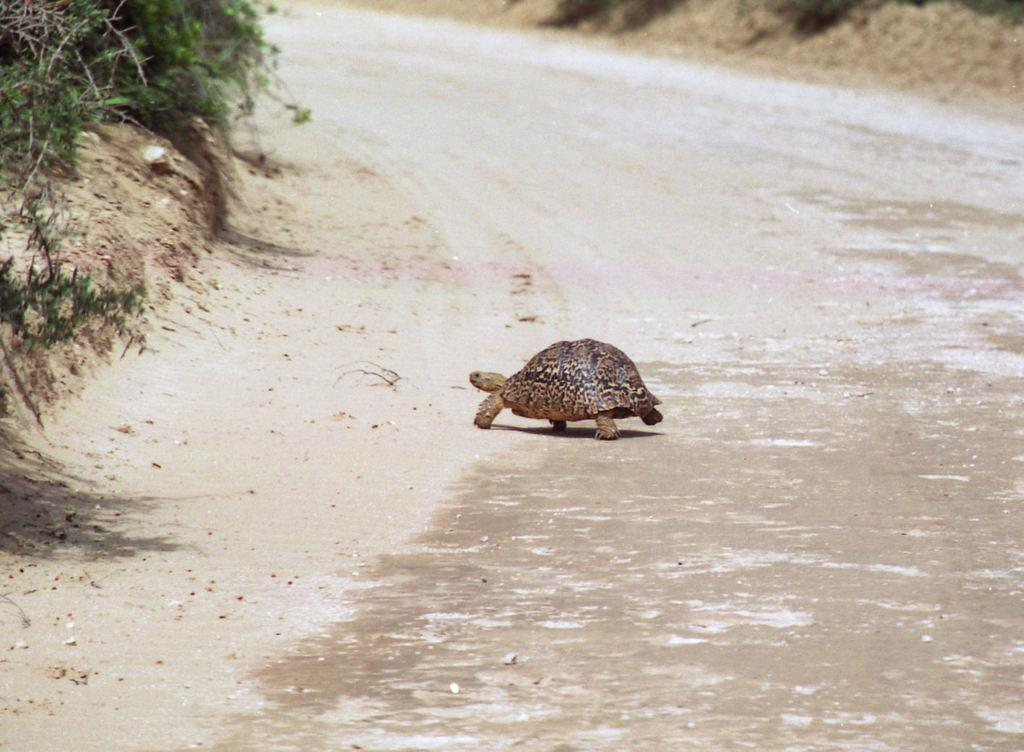What animal is present in the image? There is a tortoise in the image. Where is the tortoise located? The tortoise is on the ground. What can be seen in the background of the image? There are trees in the background of the image. What is the tortoise attacking in the image? The tortoise is not attacking anything in the image. --- Facts: 1. There is a car in the image. 2. The car is red. 3. The car has four wheels. 4. There is a person standing next to the car. 5. The person is holding a phone. Absurd Topics: dinosaur, piano, ocean Conversation: What is the main subject in the image? There is a car in the image. What color is the car? The car is red. How many wheels does the car have? The car has four wheels. Is there a person in the image? Yes, there is a person standing next to the car. What is the person holding? The person is holding a phone. Reasoning: Let's think step by step in order to ${produce the conversation}. We start by identifying the main subject of the image, which is the car. Next, we describe specific features of the car, such as the color and the number of wheels. Then, we observe the actions of the person in the image, noting that they are holding a phone. Finally, we ensure that the language is simple and clear. Absurd Question/Answer: Can you see a dinosaur playing a piano in the ocean in the image? No, there is no dinosaur playing a piano in the ocean in the image. 